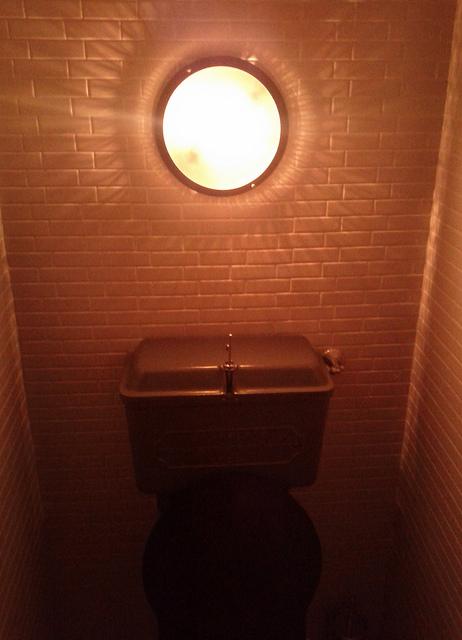Can you pee in this room?
Be succinct. Yes. Is the wall made of brick?
Keep it brief. Yes. What is under the window?
Be succinct. Toilet. 